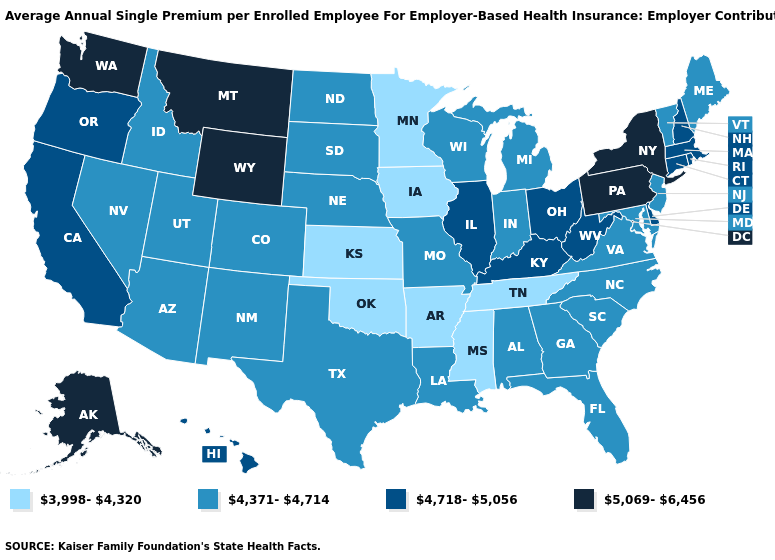Name the states that have a value in the range 5,069-6,456?
Answer briefly. Alaska, Montana, New York, Pennsylvania, Washington, Wyoming. Does the map have missing data?
Short answer required. No. What is the value of Washington?
Concise answer only. 5,069-6,456. What is the value of Maryland?
Quick response, please. 4,371-4,714. Does Arkansas have a higher value than Minnesota?
Give a very brief answer. No. What is the value of California?
Short answer required. 4,718-5,056. Does Hawaii have a lower value than Washington?
Give a very brief answer. Yes. Among the states that border Kansas , which have the lowest value?
Write a very short answer. Oklahoma. Name the states that have a value in the range 4,371-4,714?
Give a very brief answer. Alabama, Arizona, Colorado, Florida, Georgia, Idaho, Indiana, Louisiana, Maine, Maryland, Michigan, Missouri, Nebraska, Nevada, New Jersey, New Mexico, North Carolina, North Dakota, South Carolina, South Dakota, Texas, Utah, Vermont, Virginia, Wisconsin. What is the value of New Jersey?
Keep it brief. 4,371-4,714. Does Idaho have the lowest value in the West?
Concise answer only. Yes. Does Iowa have the lowest value in the USA?
Give a very brief answer. Yes. What is the highest value in the MidWest ?
Give a very brief answer. 4,718-5,056. Does New York have the highest value in the USA?
Be succinct. Yes. Name the states that have a value in the range 4,718-5,056?
Write a very short answer. California, Connecticut, Delaware, Hawaii, Illinois, Kentucky, Massachusetts, New Hampshire, Ohio, Oregon, Rhode Island, West Virginia. 